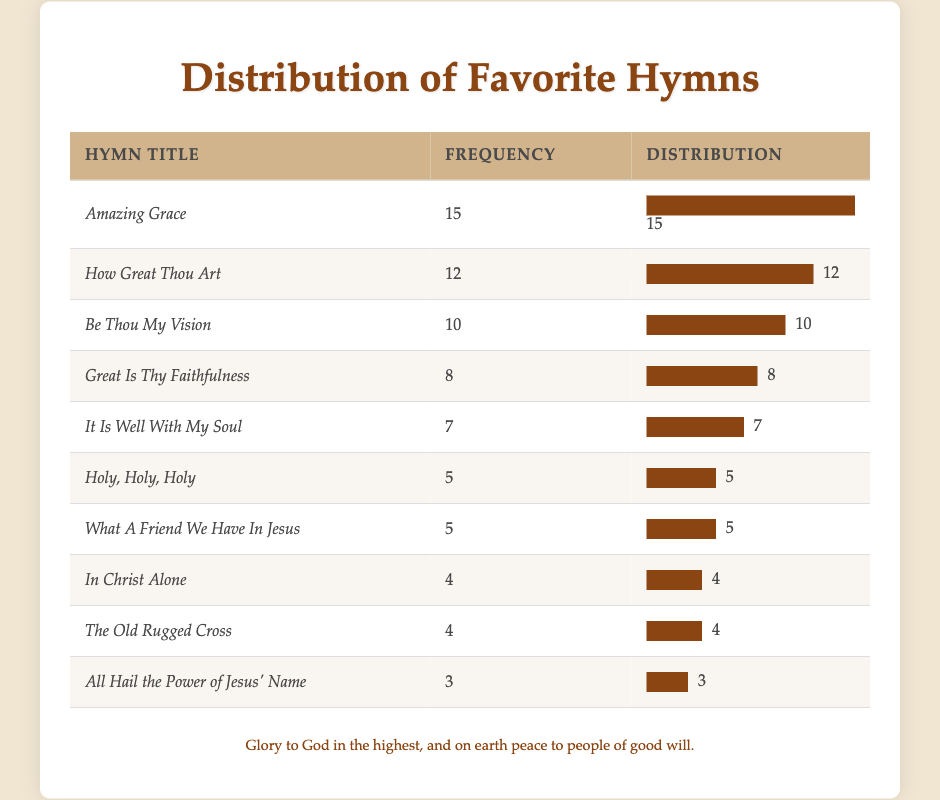What hymn has the highest frequency among the congregation members? The hymn with the highest frequency is "Amazing Grace" with a frequency of 15, which is directly stated in the table as the first entry.
Answer: Amazing Grace How many members chose "Great Is Thy Faithfulness" as their favorite hymn? The table lists "Great Is Thy Faithfulness" with a frequency of 8. This value is found in the respective row for this hymn in the table.
Answer: 8 Are there more members that prefer "Holy, Holy, Holy" or "What A Friend We Have In Jesus"? Both hymns have a frequency of 5, so the number of members who prefer each is equal. This can be determined by comparing the frequencies of both hymns in the table.
Answer: No, they are equal What is the total number of votes for the top three hymns? To find the total, we add the frequencies of the top three hymns: "Amazing Grace" (15) + "How Great Thou Art" (12) + "Be Thou My Vision" (10) = 37. This involves summing the frequencies for these three hymns.
Answer: 37 Which hymn titles have a frequency of 4? "In Christ Alone" and "The Old Rugged Cross" both have a frequency of 4, as shown in the table. This can be found by scanning the table for rows with that specific frequency.
Answer: In Christ Alone, The Old Rugged Cross What is the average frequency of the hymns listed in the table? To calculate the average frequency, sum all frequencies (15 + 12 + 10 + 8 + 7 + 5 + 5 + 4 + 4 + 3 = 69) and then divide by the number of hymns (10). Therefore, the average is 69/10 = 6.9. This involves performing the sum of the frequencies followed by the division.
Answer: 6.9 Are there any hymns with a frequency of 3, and if so, how many? Yes, there is one hymn with a frequency of 3. This hymn is "All Hail the Power of Jesus' Name," as indicated in the table. The response involves checking for any listings with this specific frequency.
Answer: Yes, one hymn Which hymn has a frequency that is exactly halfway between the highest and lowest frequencies? The highest frequency is 15 (Amazing Grace) and the lowest is 3 (All Hail the Power of Jesus' Name), so halfway would be (15 + 3) / 2 = 9. The hymn "Be Thou My Vision" has a frequency of 10, which is the closest to 9. This requires calculating the halfway point and checking the closest hymn frequency to that value.
Answer: Be Thou My Vision 